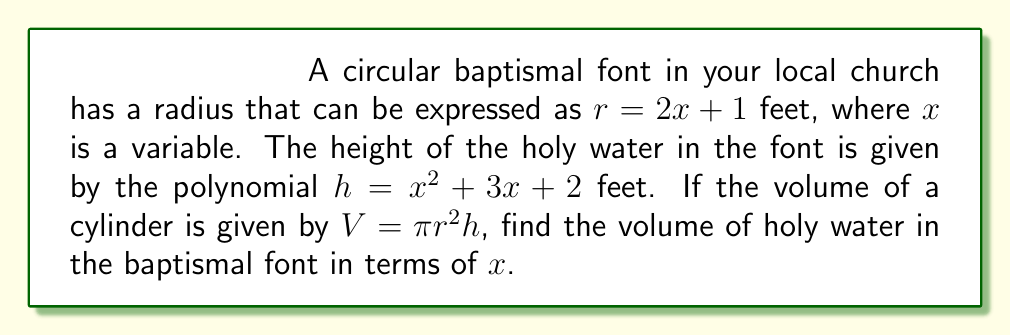What is the answer to this math problem? Let's approach this step-by-step:

1) We're given that the radius $r = 2x + 1$ and the height $h = x^2 + 3x + 2$.

2) The volume of a cylinder is given by $V = \pi r^2 h$.

3) Let's substitute our expressions for $r$ and $h$ into this formula:

   $V = \pi (2x + 1)^2 (x^2 + 3x + 2)$

4) Let's expand $(2x + 1)^2$:
   $(2x + 1)^2 = 4x^2 + 4x + 1$

5) Now our volume equation looks like this:

   $V = \pi (4x^2 + 4x + 1)(x^2 + 3x + 2)$

6) Let's multiply these polynomials:

   $V = \pi (4x^4 + 12x^3 + 8x^2 + 4x^3 + 12x^2 + 8x + x^2 + 3x + 2)$

7) Simplify by combining like terms:

   $V = \pi (4x^4 + 16x^3 + 21x^2 + 11x + 2)$

8) This is our final polynomial expression for the volume of holy water in the baptismal font.
Answer: $V = \pi (4x^4 + 16x^3 + 21x^2 + 11x + 2)$ cubic feet 